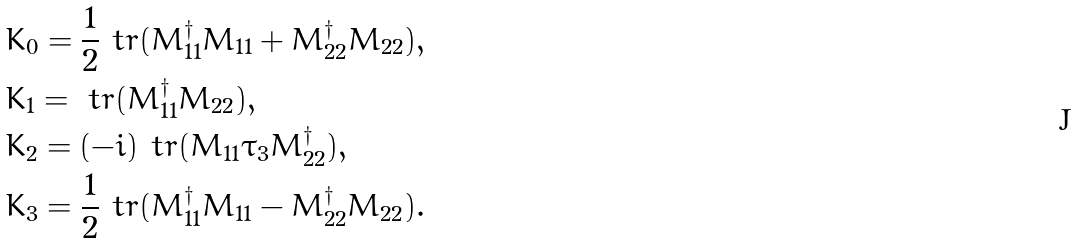Convert formula to latex. <formula><loc_0><loc_0><loc_500><loc_500>& K _ { 0 } = \frac { 1 } { 2 } \ t r ( M _ { 1 1 } ^ { \dagger } M _ { 1 1 } + M _ { 2 2 } ^ { \dagger } M _ { 2 2 } ) , \\ & K _ { 1 } = \ t r ( M _ { 1 1 } ^ { \dagger } M _ { 2 2 } ) , \\ & K _ { 2 } = ( - i ) \ t r ( M _ { 1 1 } \tau _ { 3 } M _ { 2 2 } ^ { \dagger } ) , \\ & K _ { 3 } = \frac { 1 } { 2 } \ t r ( M _ { 1 1 } ^ { \dagger } M _ { 1 1 } - M _ { 2 2 } ^ { \dagger } M _ { 2 2 } ) .</formula> 